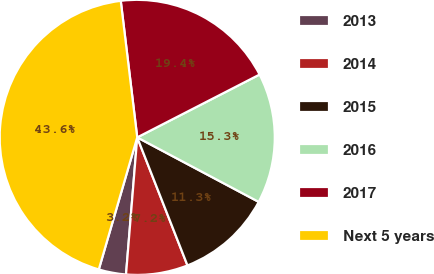Convert chart to OTSL. <chart><loc_0><loc_0><loc_500><loc_500><pie_chart><fcel>2013<fcel>2014<fcel>2015<fcel>2016<fcel>2017<fcel>Next 5 years<nl><fcel>3.21%<fcel>7.25%<fcel>11.28%<fcel>15.32%<fcel>19.36%<fcel>43.58%<nl></chart> 